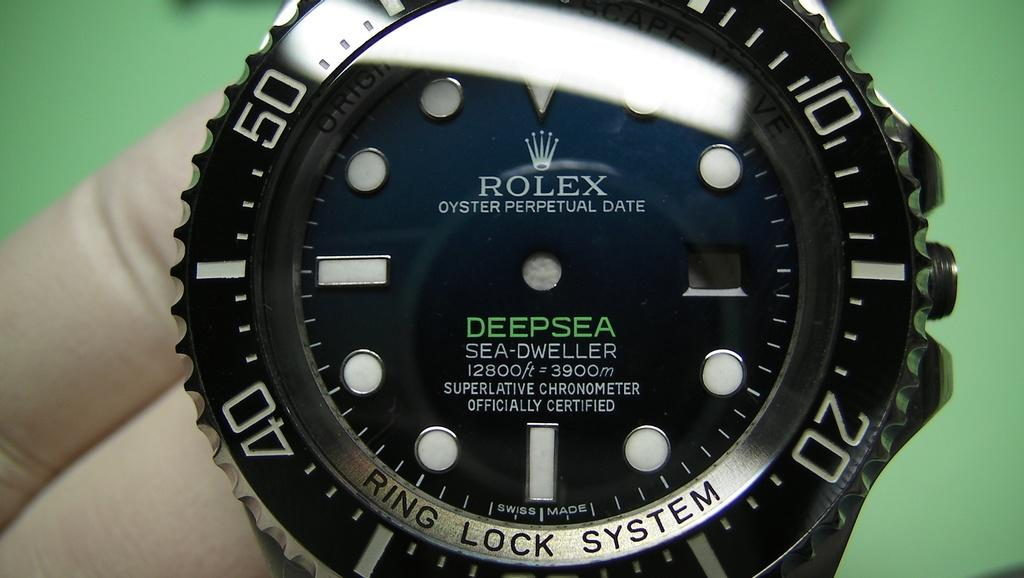Provide a one-sentence caption for the provided image. A deep sea Rolex watch is seen close up which has no hands. 